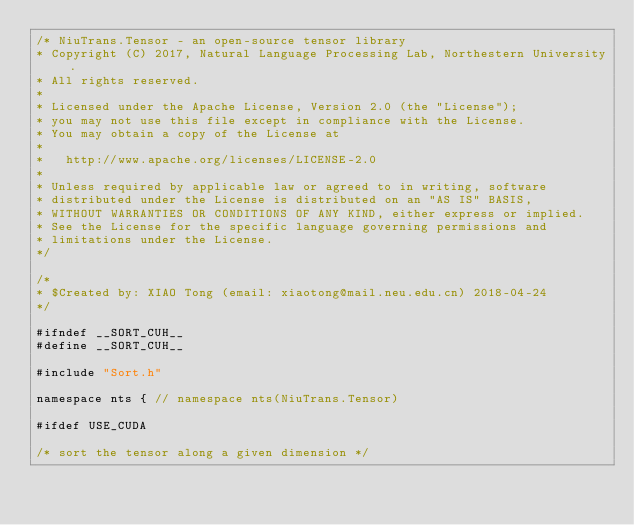Convert code to text. <code><loc_0><loc_0><loc_500><loc_500><_Cuda_>/* NiuTrans.Tensor - an open-source tensor library
* Copyright (C) 2017, Natural Language Processing Lab, Northestern University.
* All rights reserved.
*
* Licensed under the Apache License, Version 2.0 (the "License");
* you may not use this file except in compliance with the License.
* You may obtain a copy of the License at
*
*   http://www.apache.org/licenses/LICENSE-2.0
*
* Unless required by applicable law or agreed to in writing, software
* distributed under the License is distributed on an "AS IS" BASIS,
* WITHOUT WARRANTIES OR CONDITIONS OF ANY KIND, either express or implied.
* See the License for the specific language governing permissions and
* limitations under the License.
*/

/*
* $Created by: XIAO Tong (email: xiaotong@mail.neu.edu.cn) 2018-04-24
*/

#ifndef __SORT_CUH__
#define __SORT_CUH__

#include "Sort.h"

namespace nts { // namespace nts(NiuTrans.Tensor)

#ifdef USE_CUDA

/* sort the tensor along a given dimension */</code> 